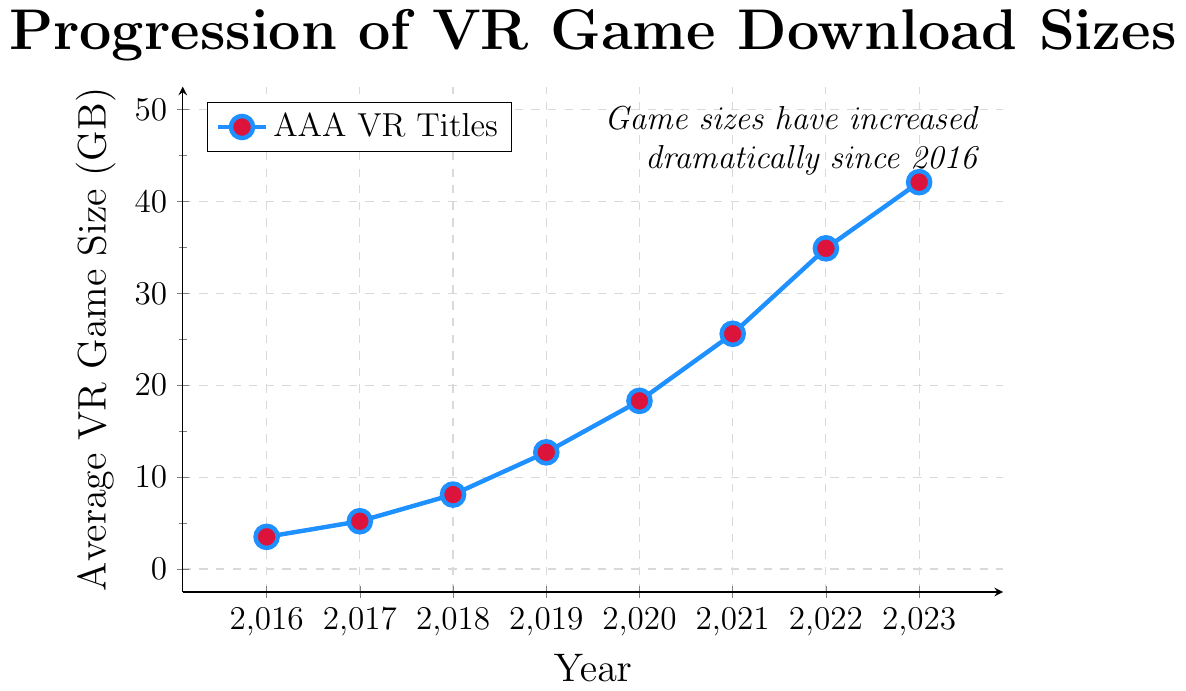What was the average VR game size in 2019? The point corresponding to the year 2019 plots at 12.7 GB.
Answer: 12.7 GB How much did the average VR game size increase from 2016 to 2023? The average game size in 2016 was 3.5 GB, and in 2023 it was 42.1 GB. The increase is the difference between these values: 42.1 - 3.5 = 38.6 GB.
Answer: 38.6 GB Which year saw the largest increase in average VR game sizes? By evaluating the year-on-year increases: from 2016 to 2017 (5.2 - 3.5 = 1.7 GB), from 2017 to 2018 (8.1 - 5.2 = 2.9 GB), from 2018 to 2019 (12.7 - 8.1 = 4.6 GB), from 2019 to 2020 (18.3 - 12.7 = 5.6 GB), from 2020 to 2021 (25.6 - 18.3 = 7.3 GB), from 2021 to 2022 (34.9 - 25.6 = 9.3 GB), from 2022 to 2023 (42.1 - 34.9 = 7.2 GB). The largest increase occurred between 2021 and 2022.
Answer: 2021-2022 What was the average increase in VR game size per year from 2016 to 2023? The total increase over the period 2016 to 2023 is 42.1 - 3.5 = 38.6 GB. There are 7 intervals (2016-2017, 2017-2018, etc.). So, the average increase per year is 38.6 / 7 ≈ 5.51 GB.
Answer: Approximately 5.51 GB Compare the data points for 2017 and 2020. Which year had a higher VR game size and by how much? The game size in 2017 was 5.2 GB and in 2020 it was 18.3 GB. The difference is 18.3 - 5.2 = 13.1 GB.
Answer: 2020 by 13.1 GB Estimate the visual trend shown in the chart. Has the growth rate of VR game sizes been consistent, or has it increased/decreased over the years? Observing the line trends, the increases between 2016-2017 and 2017-2018 are smaller compared to 2019 onwards. This suggests that the growth rate has increased over the years.
Answer: Increased growth rate Which data point in the series is represented by a red-filled mark? All data points are represented by blue lines with red-filled marks.
Answer: All points What is the average VR game size between 2016 and 2020 inclusive? Sum the sizes from 2016 to 2020 (3.5 + 5.2 + 8.1 + 12.7 + 18.3 = 47.8). The average is 47.8 / 5 = 9.56 GB.
Answer: 9.56 GB By how much did the average VR game size from 2021 compare to the value in 2018? In 2018, the size was 8.1 GB, and in 2021 it was 25.6 GB. The difference is 25.6 - 8.1 = 17.5 GB.
Answer: 17.5 GB How did the game size change visually from 2019 to 2020 compared to that from 2022 to 2023? The increase from 2019 to 2020 was smaller (12.7 to 18.3, an increase of 5.6 GB) compared to the increase from 2022 to 2023 (34.9 to 42.1, an increase of 7.2 GB).
Answer: Smaller increase in 2019-2020 